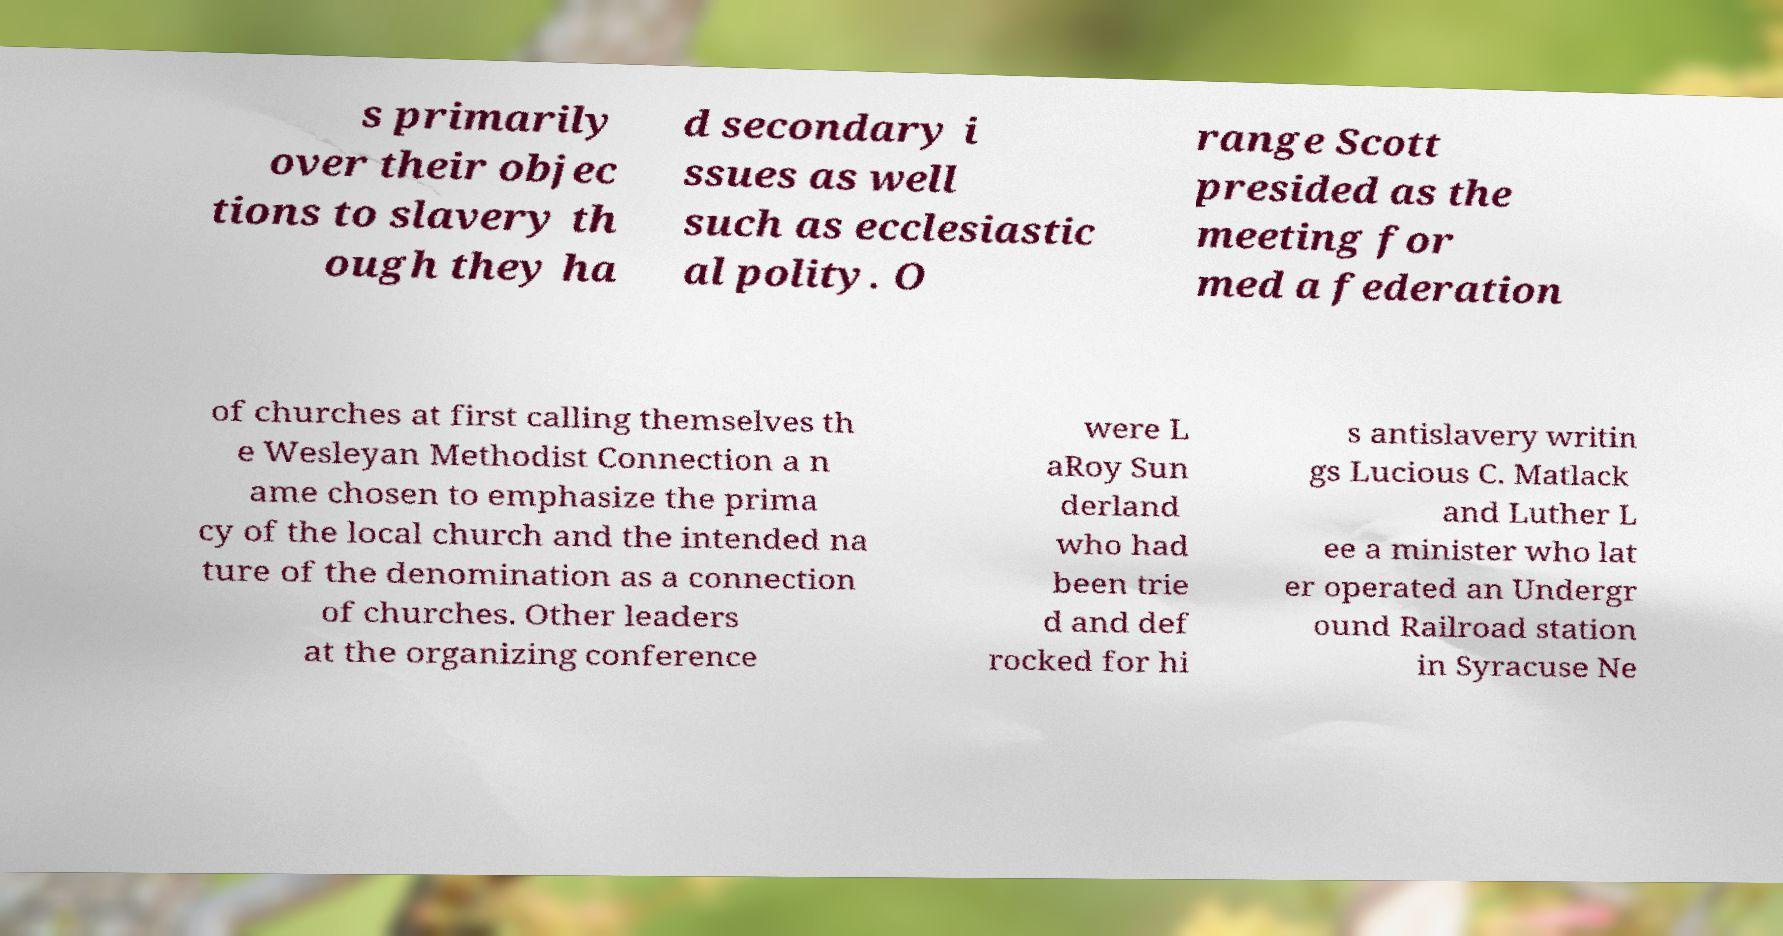Could you extract and type out the text from this image? s primarily over their objec tions to slavery th ough they ha d secondary i ssues as well such as ecclesiastic al polity. O range Scott presided as the meeting for med a federation of churches at first calling themselves th e Wesleyan Methodist Connection a n ame chosen to emphasize the prima cy of the local church and the intended na ture of the denomination as a connection of churches. Other leaders at the organizing conference were L aRoy Sun derland who had been trie d and def rocked for hi s antislavery writin gs Lucious C. Matlack and Luther L ee a minister who lat er operated an Undergr ound Railroad station in Syracuse Ne 